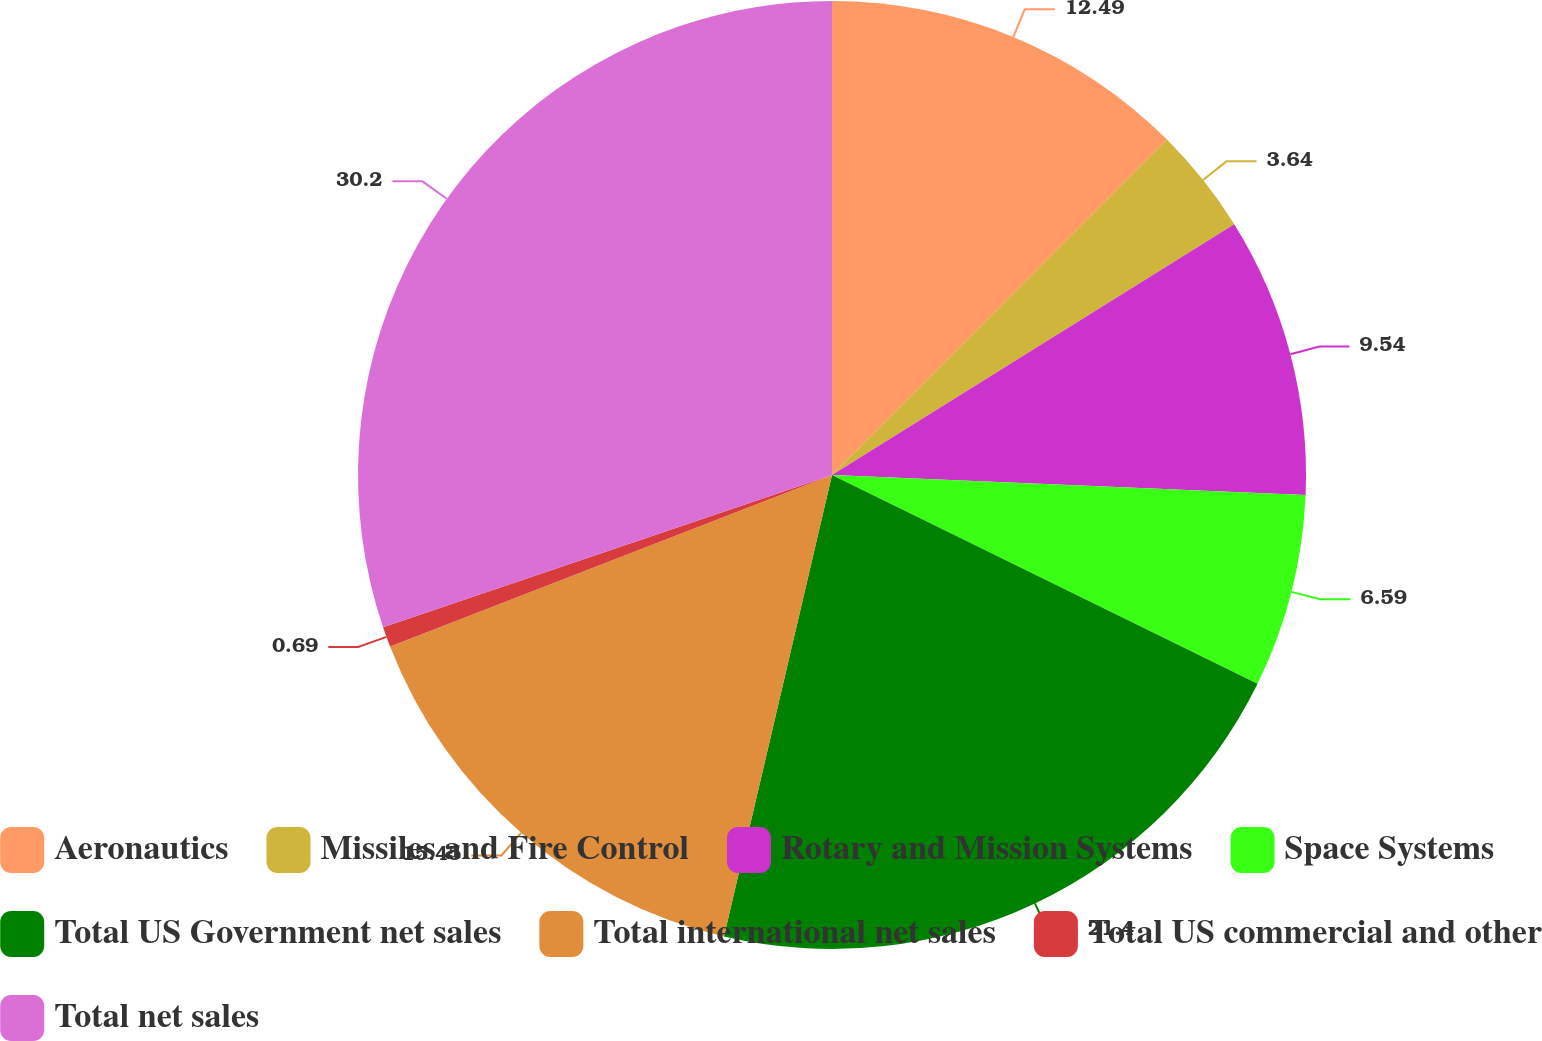Convert chart. <chart><loc_0><loc_0><loc_500><loc_500><pie_chart><fcel>Aeronautics<fcel>Missiles and Fire Control<fcel>Rotary and Mission Systems<fcel>Space Systems<fcel>Total US Government net sales<fcel>Total international net sales<fcel>Total US commercial and other<fcel>Total net sales<nl><fcel>12.49%<fcel>3.64%<fcel>9.54%<fcel>6.59%<fcel>21.4%<fcel>15.45%<fcel>0.69%<fcel>30.2%<nl></chart> 